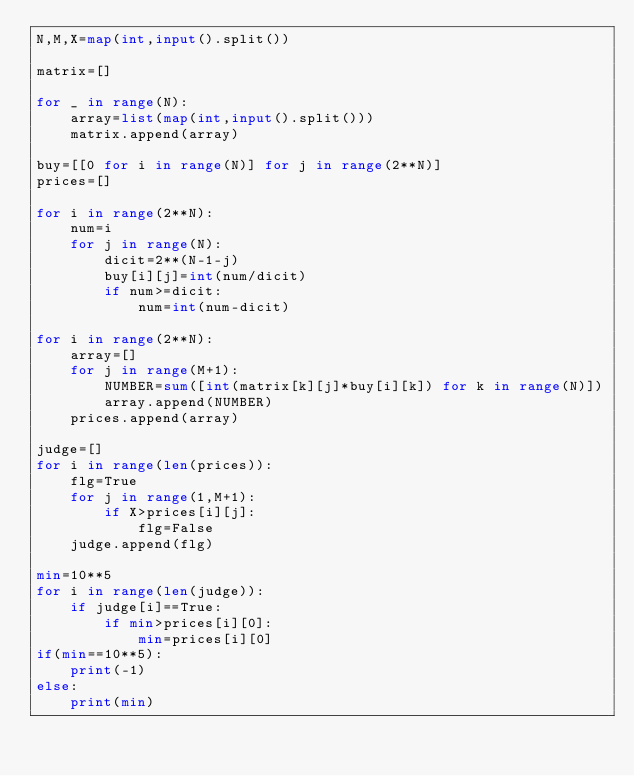<code> <loc_0><loc_0><loc_500><loc_500><_Python_>N,M,X=map(int,input().split())

matrix=[]

for _ in range(N):
    array=list(map(int,input().split()))
    matrix.append(array)

buy=[[0 for i in range(N)] for j in range(2**N)]
prices=[]

for i in range(2**N):
    num=i
    for j in range(N):
        dicit=2**(N-1-j)
        buy[i][j]=int(num/dicit)
        if num>=dicit:
            num=int(num-dicit)

for i in range(2**N):
    array=[]
    for j in range(M+1):
        NUMBER=sum([int(matrix[k][j]*buy[i][k]) for k in range(N)])
        array.append(NUMBER)
    prices.append(array)

judge=[]
for i in range(len(prices)):
    flg=True
    for j in range(1,M+1):
        if X>prices[i][j]:
            flg=False
    judge.append(flg)

min=10**5
for i in range(len(judge)):
    if judge[i]==True:
        if min>prices[i][0]:
            min=prices[i][0]
if(min==10**5):
    print(-1)
else:
    print(min)</code> 